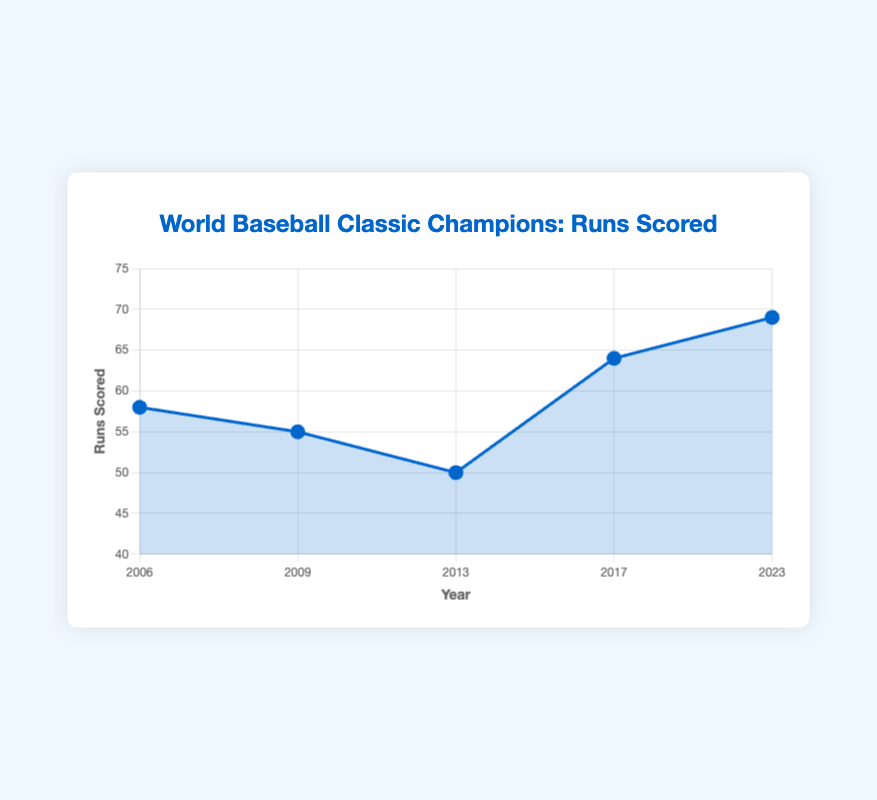What's the trend in the runs scored by champion teams over the years? The data shows how the number of runs scored by champion teams fluctuates over the years. Starting from 58 runs in 2006, it slightly decreased to 55 in 2009, continued to decrease to 50 in 2013, then increased significantly to 64 in 2017, and further increased to 69 in 2023. This indicates an overall increasing trend in recent years.
Answer: Increasing trend Which team scored the highest runs and in which year? By examining the highest point on the line chart, we see that the peak occurs at 2023 with 69 runs scored. The tooltip shows that the champion team during this year is Japan.
Answer: Japan in 2023 How many more runs did the United States score compared to the Dominican Republic? In the figure, the runs scored by the United States in 2017 is 64, and the runs scored by the Dominican Republic in 2013 is 50. By calculating the difference, we get 64 - 50 = 14.
Answer: 14 How does the performance of Japan in 2006 compare to its performance in 2023? To compare Japan's performance, we look at the runs scored by Japan in both years, which are 58 in 2006 and 69 in 2023. Japan scored 69 - 58 = 11 more runs in 2023 compared to 2006.
Answer: 11 more runs in 2023 What is the average number of runs scored by the champion teams over these years? To find the average, we sum up the runs scored (58 + 55 + 50 + 64 + 69 = 296) and divide by the number of years (5). Therefore, the average is 296 / 5 = 59.2.
Answer: 59.2 During which years did Japan win the championship, and what were their respective runs scored? By looking at the tooltip for the years Japan is mentioned, we see that Japan won in 2006, 2009, and 2023 with runs scored being 58, 55, and 69 respectively.
Answer: 2006 (58), 2009 (55), 2023 (69) What is the difference in runs scored between the lowest and highest scoring champion teams? The figure shows that Dominican Republic in 2013 scored the lowest with 50 runs, and Japan in 2023 scored the highest with 69 runs. The difference is 69 - 50 = 19.
Answer: 19 